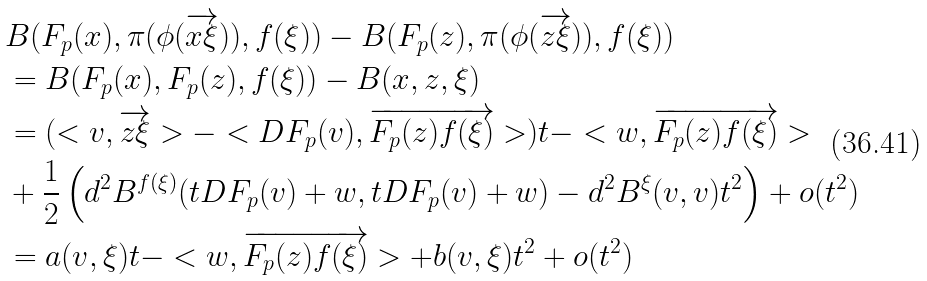<formula> <loc_0><loc_0><loc_500><loc_500>& B ( F _ { p } ( x ) , \pi ( \phi ( \overrightarrow { x \xi } ) ) , f ( \xi ) ) - B ( F _ { p } ( z ) , \pi ( \phi ( \overrightarrow { z \xi } ) ) , f ( \xi ) ) \\ & = B ( F _ { p } ( x ) , F _ { p } ( z ) , f ( \xi ) ) - B ( x , z , \xi ) \\ & = ( < v , \overrightarrow { z \xi } > - < D F _ { p } ( v ) , \overrightarrow { F _ { p } ( z ) f ( \xi ) } > ) t - < w , \overrightarrow { F _ { p } ( z ) f ( \xi ) } > \\ & + \frac { 1 } { 2 } \left ( d ^ { 2 } B ^ { f ( \xi ) } ( t D F _ { p } ( v ) + w , t D F _ { p } ( v ) + w ) - d ^ { 2 } B ^ { \xi } ( v , v ) t ^ { 2 } \right ) + o ( t ^ { 2 } ) \\ & = a ( v , \xi ) t - < w , \overrightarrow { F _ { p } ( z ) f ( \xi ) } > + b ( v , \xi ) t ^ { 2 } + o ( t ^ { 2 } ) \\</formula> 